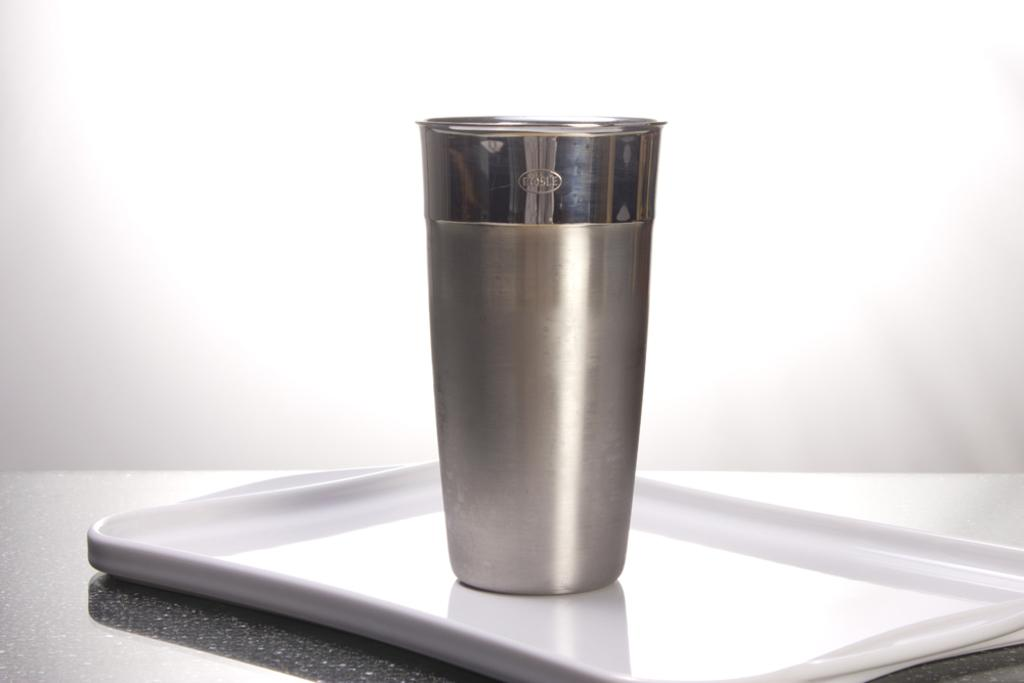What is on the tray in the image? There is a glass on a tray in the image. Where is the tray located? The tray is on a table. What color is the background of the image? The background of the image is white. What type of linen is being used to dry the glass in the image? There is no linen or drying activity present in the image; it only shows a glass on a tray on a table with a white background. 